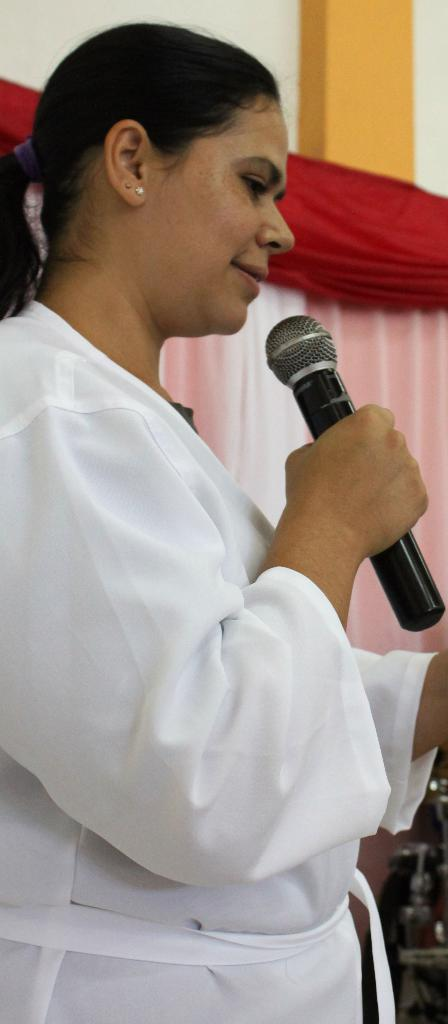Who is the main subject in the image? There is a woman in the image. What is the woman holding in her hand? The woman is holding a microphone in her hand. What is the woman doing with the microphone? The woman is talking. What can be seen in the background of the image? There are curtains and a wall in the background of the image. How does the woman show respect to the audience in the image? The image does not provide information about the woman showing respect to the audience, as it only shows her holding a microphone and talking. 